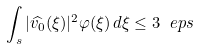<formula> <loc_0><loc_0><loc_500><loc_500>\int _ { \real s } | \widehat { v _ { 0 } } ( \xi ) | ^ { 2 } \varphi ( \xi ) \, d \xi \leq 3 \ e p s</formula> 